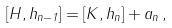Convert formula to latex. <formula><loc_0><loc_0><loc_500><loc_500>[ H , h _ { n - 1 } ] = [ K , h _ { n } ] + a _ { n } \, ,</formula> 